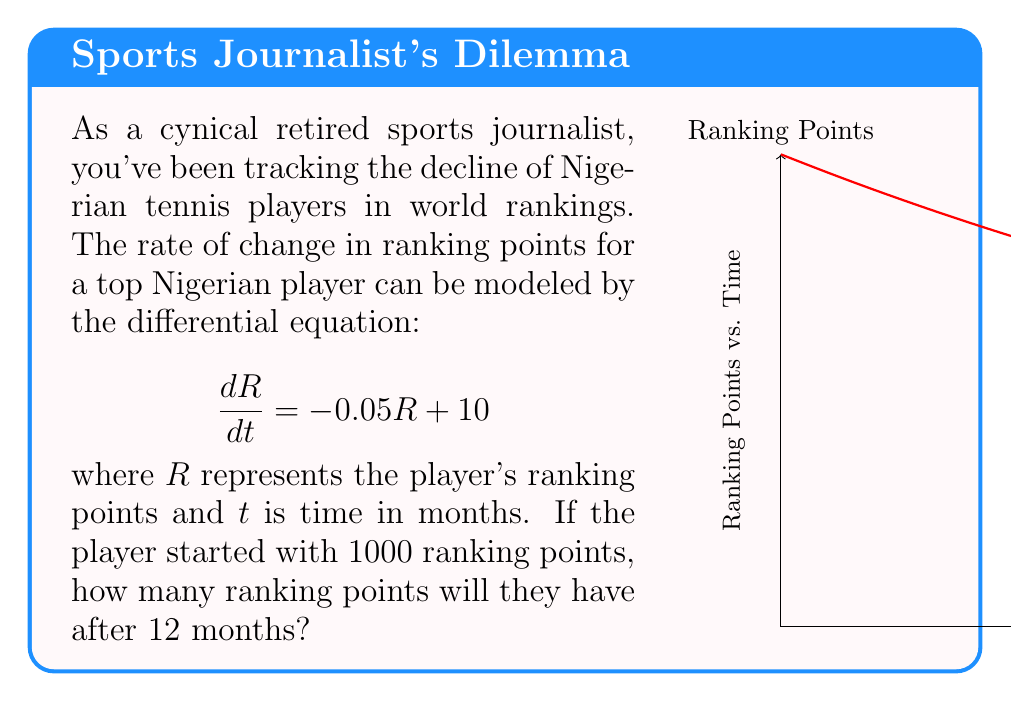Show me your answer to this math problem. To solve this problem, we need to follow these steps:

1) The given differential equation is a first-order linear differential equation:
   $$\frac{dR}{dt} = -0.05R + 10$$

2) The general solution for this type of equation is:
   $$R(t) = Ce^{-0.05t} + 200$$
   where $C$ is a constant we need to determine.

3) We know the initial condition: $R(0) = 1000$. Let's use this to find $C$:
   $$1000 = Ce^{-0.05(0)} + 200$$
   $$1000 = C + 200$$
   $$C = 800$$

4) Now we have the particular solution:
   $$R(t) = 800e^{-0.05t} + 200$$

5) To find the ranking points after 12 months, we evaluate $R(12)$:
   $$R(12) = 800e^{-0.05(12)} + 200$$
   $$R(12) = 800e^{-0.6} + 200$$
   $$R(12) \approx 800(0.5488) + 200 \approx 639.04$$

6) Rounding to the nearest whole number (as ranking points are typically integers):
   $$R(12) \approx 639$$
Answer: 639 ranking points 